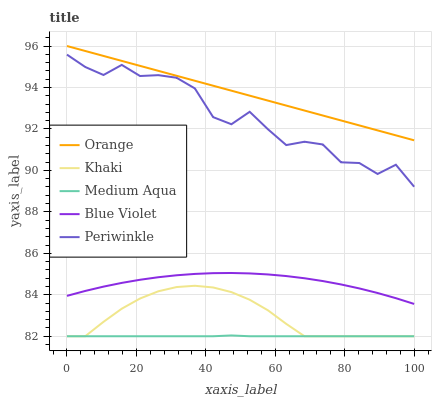Does Periwinkle have the minimum area under the curve?
Answer yes or no. No. Does Periwinkle have the maximum area under the curve?
Answer yes or no. No. Is Khaki the smoothest?
Answer yes or no. No. Is Khaki the roughest?
Answer yes or no. No. Does Periwinkle have the lowest value?
Answer yes or no. No. Does Periwinkle have the highest value?
Answer yes or no. No. Is Blue Violet less than Orange?
Answer yes or no. Yes. Is Periwinkle greater than Khaki?
Answer yes or no. Yes. Does Blue Violet intersect Orange?
Answer yes or no. No. 